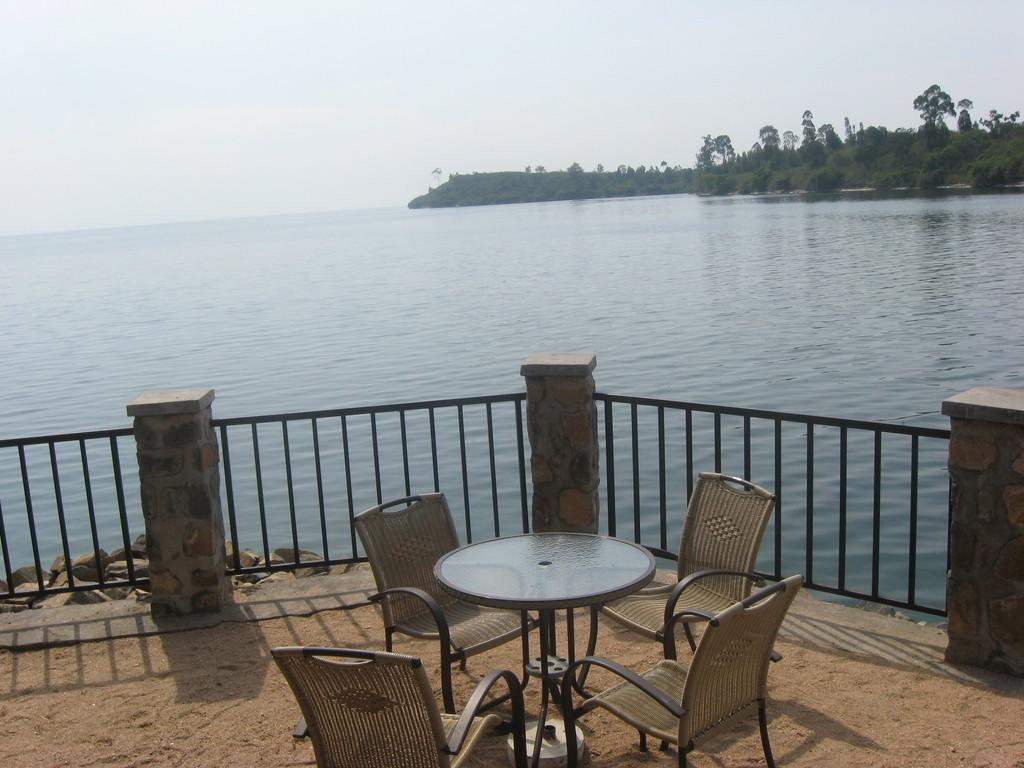What type of furniture is present in the image? There is a table in the image. How many chairs are around the table? There are four chairs in the image. What can be seen near the table? There is a railing in the image. What is visible in the background of the image? Water, trees, and a white sky are visible in the background of the image. What type of flowers are being rewarded in the image? There are no flowers or rewards present in the image. 